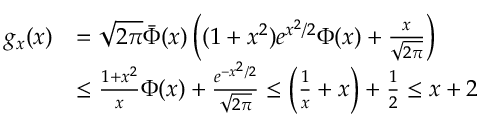<formula> <loc_0><loc_0><loc_500><loc_500>\begin{array} { r l } { g _ { x } ( x ) } & { = \sqrt { 2 \pi } \bar { \Phi } ( x ) \left ( ( 1 + x ^ { 2 } ) e ^ { x ^ { 2 } / 2 } \Phi ( x ) + \frac { x } { \sqrt { 2 \pi } } \right ) } \\ & { \leq \frac { 1 + x ^ { 2 } } { x } \Phi ( x ) + \frac { e ^ { - x ^ { 2 } / 2 } } { \sqrt { 2 \pi } } \leq \left ( \frac { 1 } { x } + x \right ) + \frac { 1 } { 2 } \leq x + 2 } \end{array}</formula> 